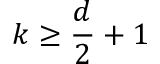<formula> <loc_0><loc_0><loc_500><loc_500>k \geq \frac { d } { 2 } + 1</formula> 